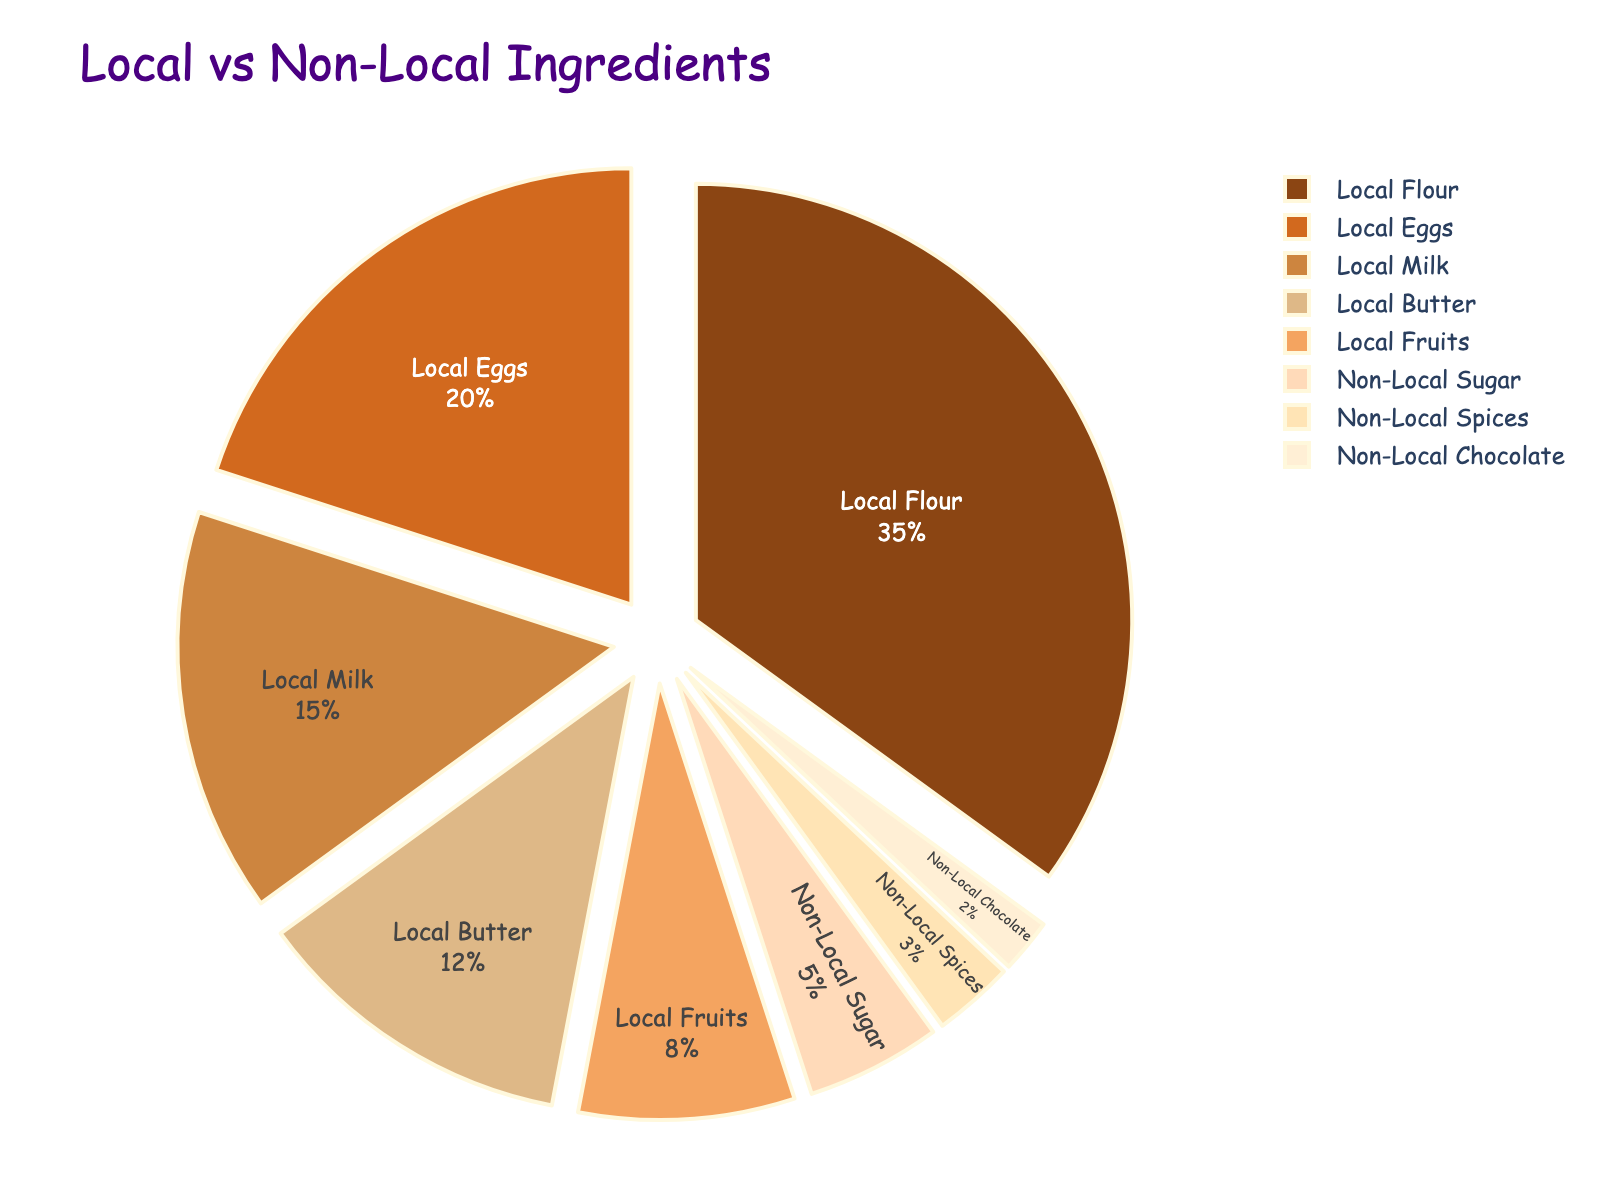Which ingredient is sourced the most from local suppliers? The ingredient with the largest percentage in the pie chart is Local Flour, which is 35%.
Answer: Local Flour Which ingredient category—local or non-local—has a higher combined percentage? Add up the percentages for all local ingredients and do the same for non-local ingredients. The total for local ingredients is 35 + 20 + 15 + 12 + 8 = 90%, while the total for non-local ingredients is 5 + 3 + 2 = 10%.
Answer: Local What's the difference in percentage between the ingredient sourced the most and the least from local suppliers? The most sourced local ingredient is Local Flour at 35%, and the least is Local Fruits at 8%. The difference is 35 - 8 = 27%.
Answer: 27% What is the combined percentage of locally sourced dairy products (Milk and Butter)? Add the percentages of Local Milk and Local Butter, which are 15% and 12%, respectively. The combined percentage is 15 + 12 = 27%.
Answer: 27% Is the percentage of local eggs higher or lower than the percentage of non-local sugar? Compare the percentage of Local Eggs (20%) and Non-Local Sugar (5%). Local Eggs have a higher percentage.
Answer: Higher What is the visual representation of non-local ingredients in terms of color? Non-Local ingredients on the pie chart are represented by three sections colored peach, light peach, and another shade of light peach corresponding to Non-Local Sugar, Spices, and Chocolate respectively.
Answer: Peach shades Which local ingredient has the closest percentage to a non-local ingredient, and what are those percentages? Compare the percentages of each ingredient. Local Butter (12%) is closest to Non-Local Sugar (5%) compared to other local ingredients.
Answer: Local Butter (12%), Non-Local Sugar (5%) By how much does the percentage of local ingredients exceed the percentage of non-local ingredients? The total percentage for local ingredients is 90% and for non-local ingredients is 10%. The difference is 90 - 10 = 80%.
Answer: 80% What percentage of the total ingredients are represented by local flour and local eggs combined? Add the percentages of Local Flour and Local Eggs, which are 35% and 20% respectively. The combined percentage is 35 + 20 = 55%.
Answer: 55% Which ingredient has the smallest representation in the chart, and what percentage is it? The smallest section in the pie chart corresponds to Non-Local Chocolate, with a percentage of 2%.
Answer: Non-Local Chocolate, 2% 